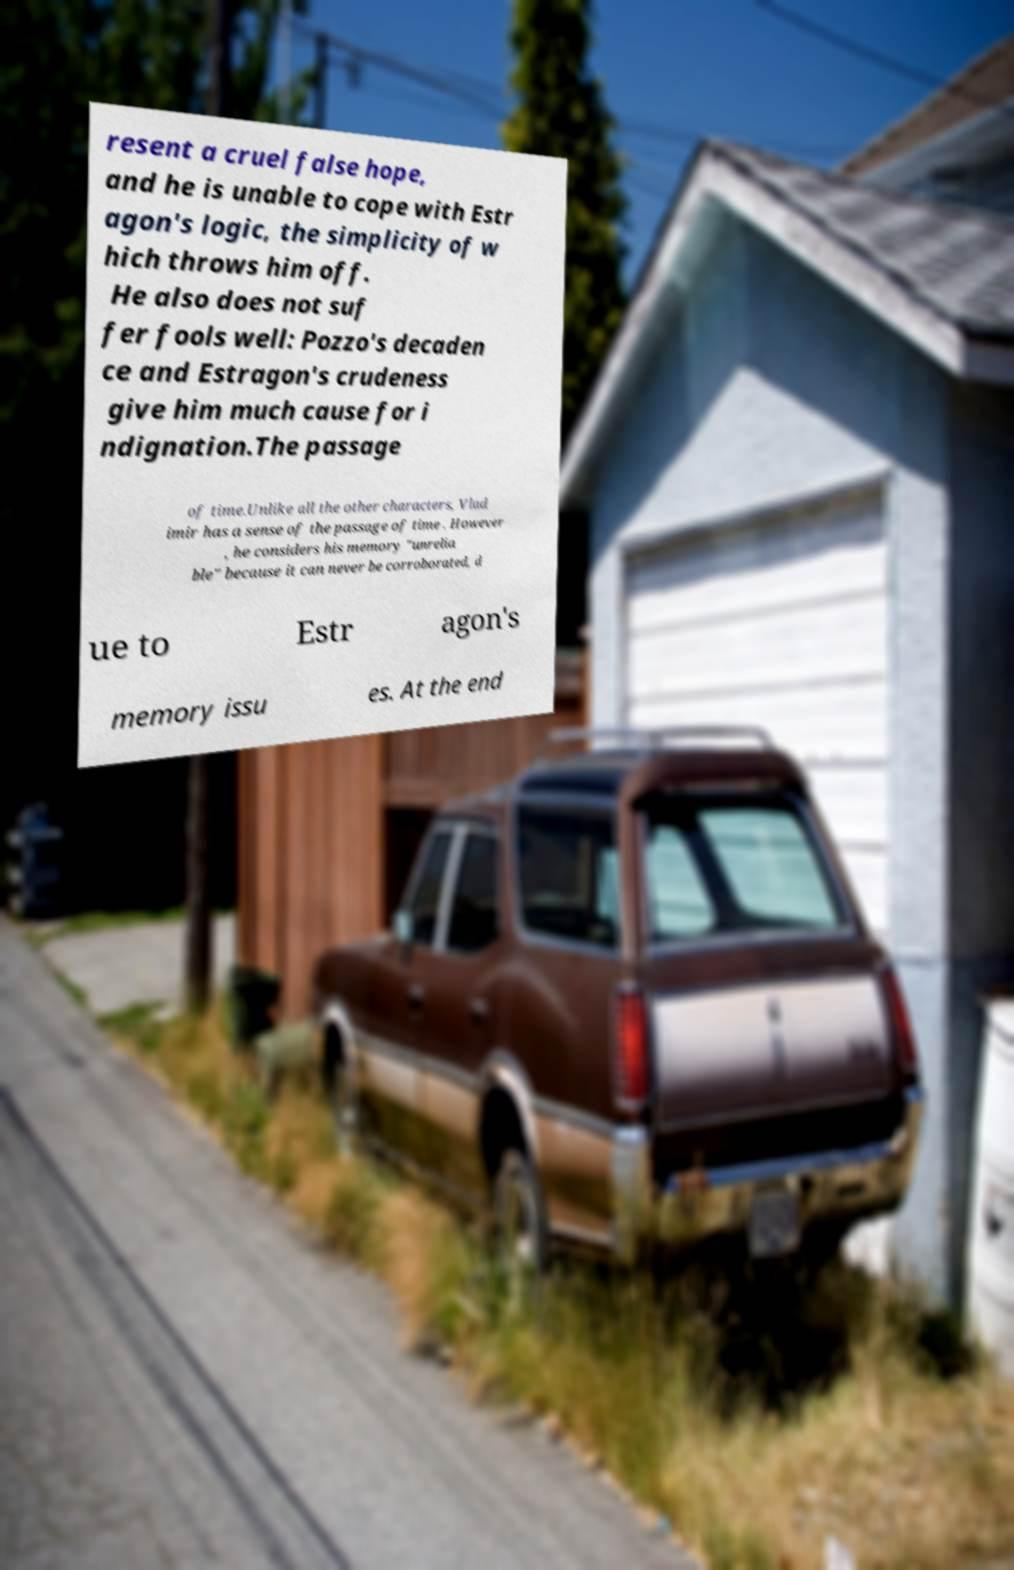Could you extract and type out the text from this image? resent a cruel false hope, and he is unable to cope with Estr agon's logic, the simplicity of w hich throws him off. He also does not suf fer fools well: Pozzo's decaden ce and Estragon's crudeness give him much cause for i ndignation.The passage of time.Unlike all the other characters, Vlad imir has a sense of the passage of time . However , he considers his memory "unrelia ble" because it can never be corroborated, d ue to Estr agon's memory issu es. At the end 